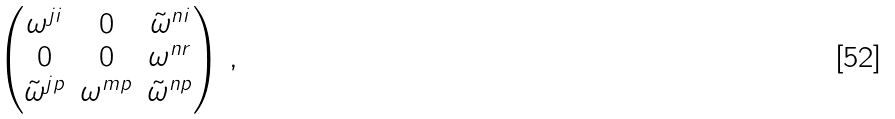<formula> <loc_0><loc_0><loc_500><loc_500>\begin{pmatrix} \omega ^ { j i } & 0 & \tilde { \omega } ^ { n i } \\ 0 & 0 & \omega ^ { n r } \\ \tilde { \omega } ^ { j p } & \omega ^ { m p } & \tilde { \omega } ^ { n p } \end{pmatrix} \, ,</formula> 